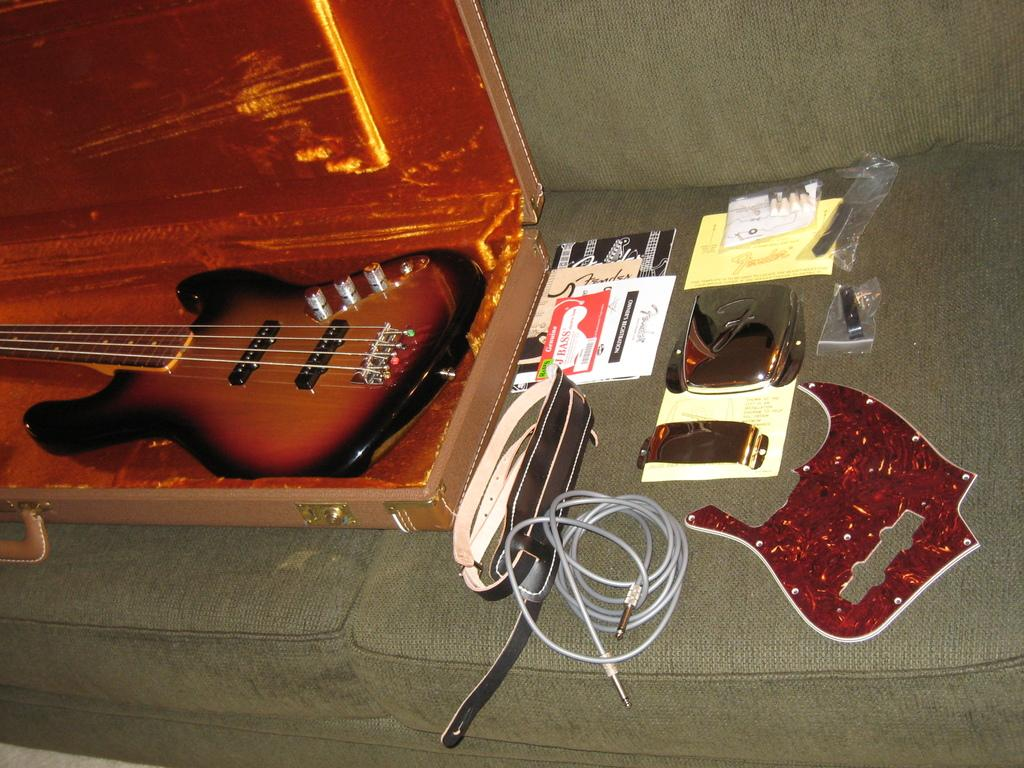What musical instrument is in the image? There is a guitar in the image. How is the guitar being stored or transported? The guitar is placed in a guitar box. What other items can be seen in the image? There are accessories on the sofa. What type of wool is being used to create a canvas in the image? There is no wool or canvas present in the image; it features a guitar in a guitar box and accessories on the sofa. 